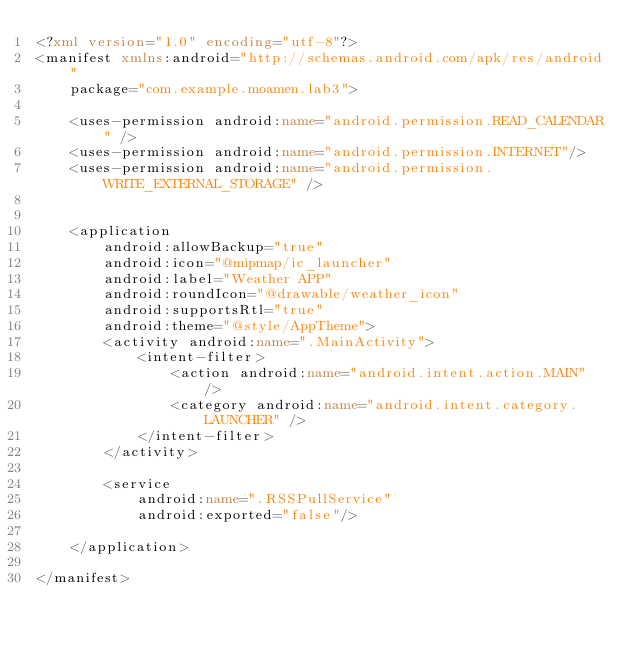<code> <loc_0><loc_0><loc_500><loc_500><_XML_><?xml version="1.0" encoding="utf-8"?>
<manifest xmlns:android="http://schemas.android.com/apk/res/android"
    package="com.example.moamen.lab3">

    <uses-permission android:name="android.permission.READ_CALENDAR" />
    <uses-permission android:name="android.permission.INTERNET"/>
    <uses-permission android:name="android.permission.WRITE_EXTERNAL_STORAGE" />


    <application
        android:allowBackup="true"
        android:icon="@mipmap/ic_launcher"
        android:label="Weather APP"
        android:roundIcon="@drawable/weather_icon"
        android:supportsRtl="true"
        android:theme="@style/AppTheme">
        <activity android:name=".MainActivity">
            <intent-filter>
                <action android:name="android.intent.action.MAIN" />
                <category android:name="android.intent.category.LAUNCHER" />
            </intent-filter>
        </activity>

        <service
            android:name=".RSSPullService"
            android:exported="false"/>

    </application>

</manifest></code> 